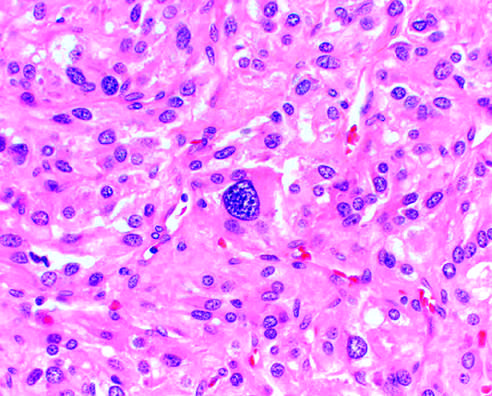s the comma-shaped residual adrenal gland seen (lower portion)?
Answer the question using a single word or phrase. Yes 